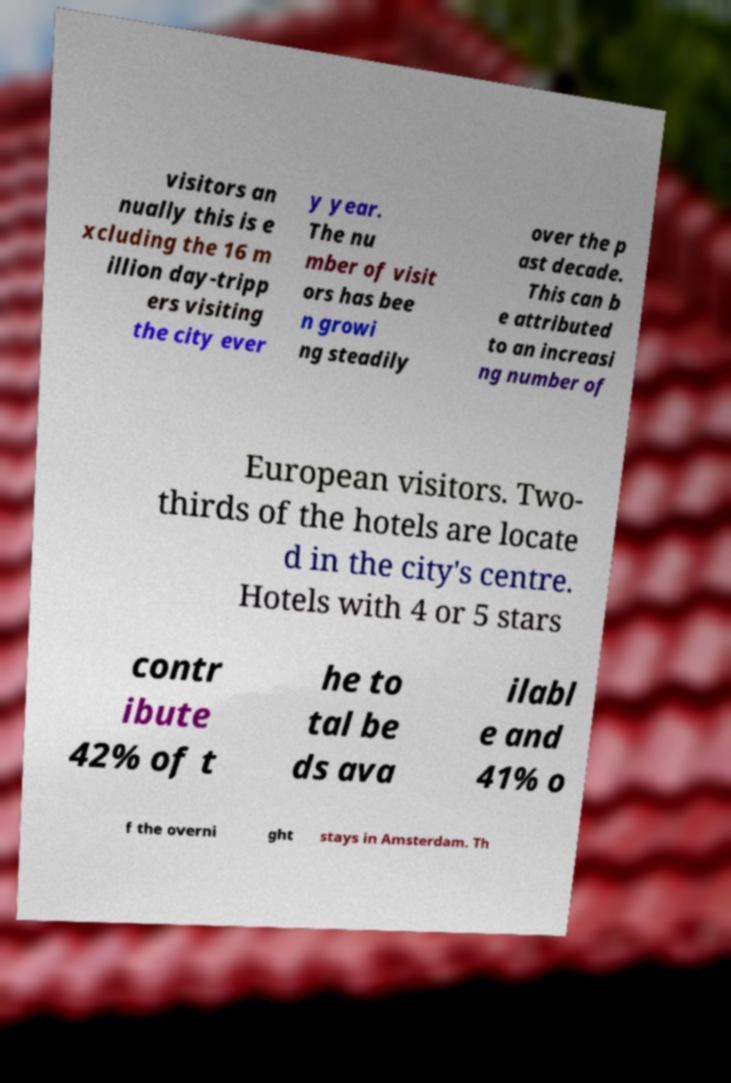Could you assist in decoding the text presented in this image and type it out clearly? visitors an nually this is e xcluding the 16 m illion day-tripp ers visiting the city ever y year. The nu mber of visit ors has bee n growi ng steadily over the p ast decade. This can b e attributed to an increasi ng number of European visitors. Two- thirds of the hotels are locate d in the city's centre. Hotels with 4 or 5 stars contr ibute 42% of t he to tal be ds ava ilabl e and 41% o f the overni ght stays in Amsterdam. Th 